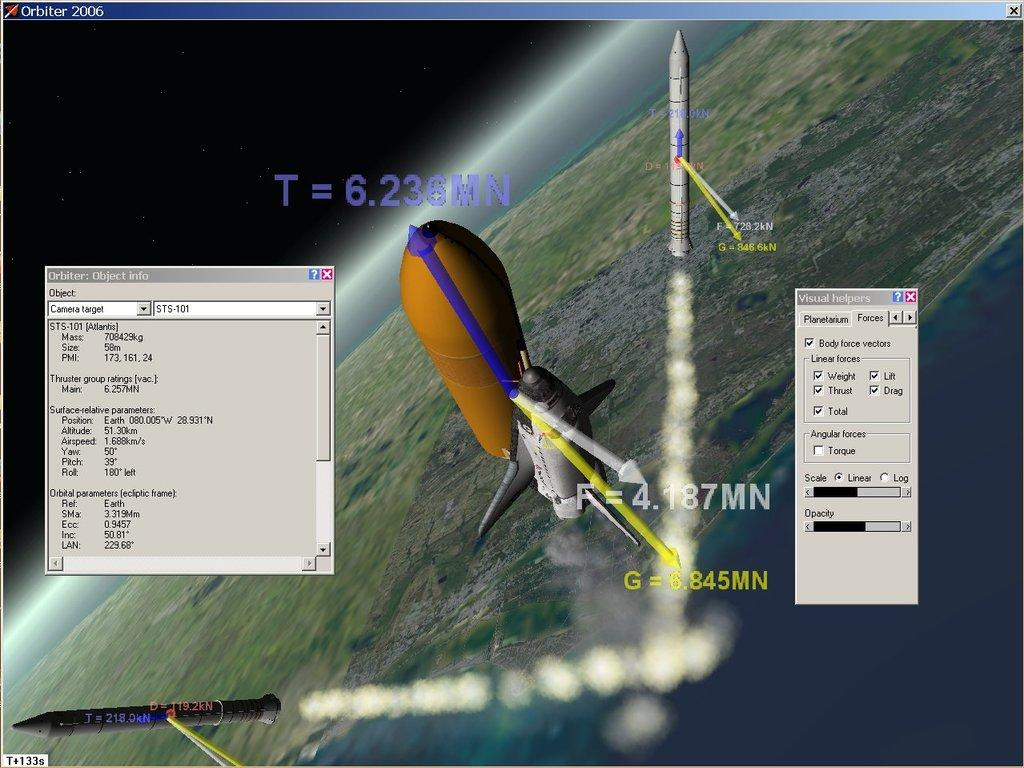What is the main subject of the image? The main subject of the image is three rockets. Can you describe the rockets in the image? The rockets are in different colors. What can be seen in the background of the image? The Earth is visible in the background of the image. What type of pet can be seen playing with a ship in the image? There is no pet or ship present in the image; it features three rockets and the Earth in the background. 